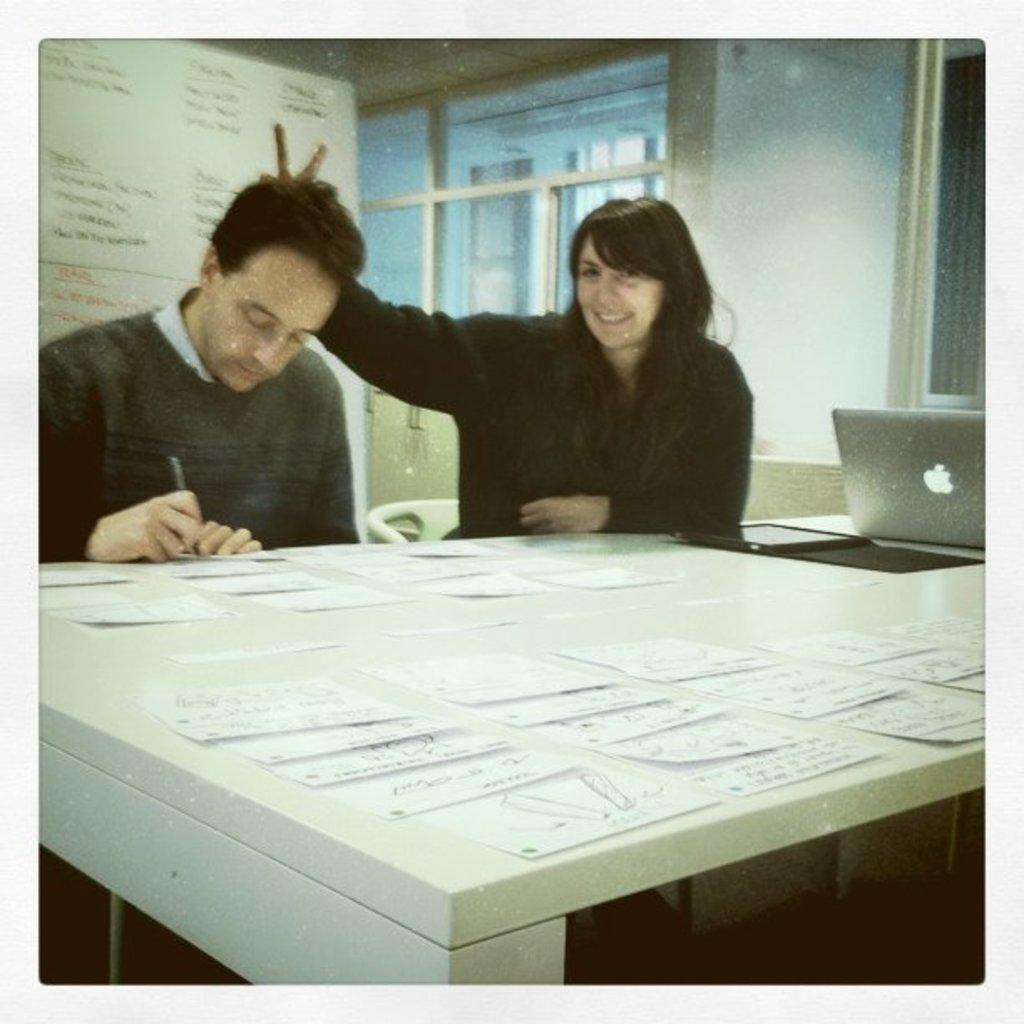Who can be seen in the image? There is a man and a woman in the image. What are the man and woman doing in the image? The man and woman are seated on chairs. What object is present on a table in the image? There is a laptop on a table in the image. Can you tell me how many zebras are in the image? There are no zebras present in the image. What country is the woman from in the image? The provided facts do not give any information about the woman's country of origin. 